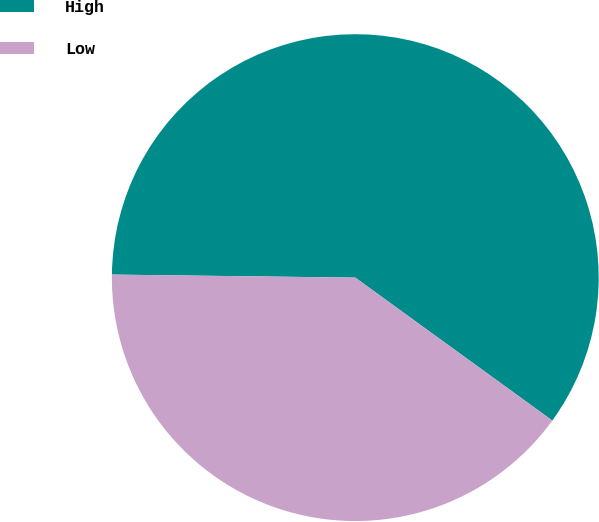Convert chart. <chart><loc_0><loc_0><loc_500><loc_500><pie_chart><fcel>High<fcel>Low<nl><fcel>59.79%<fcel>40.21%<nl></chart> 